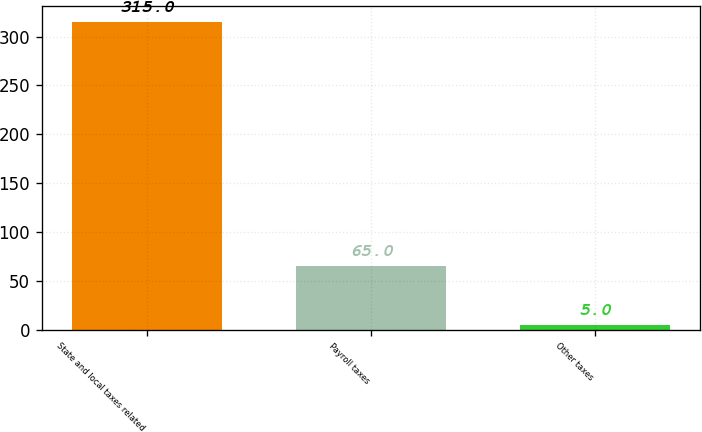Convert chart. <chart><loc_0><loc_0><loc_500><loc_500><bar_chart><fcel>State and local taxes related<fcel>Payroll taxes<fcel>Other taxes<nl><fcel>315<fcel>65<fcel>5<nl></chart> 